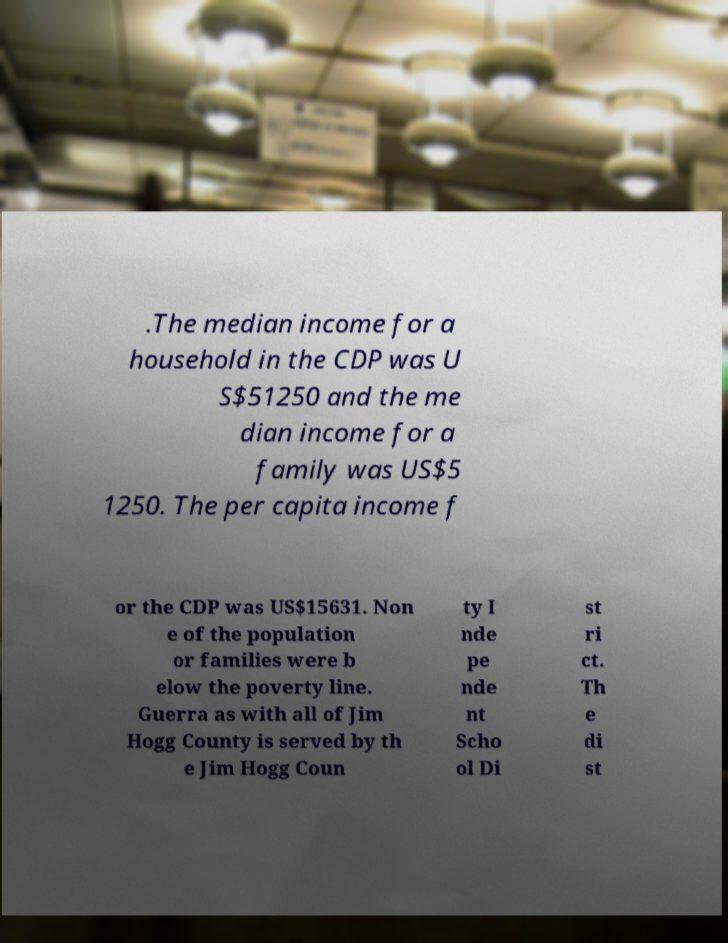Can you accurately transcribe the text from the provided image for me? .The median income for a household in the CDP was U S$51250 and the me dian income for a family was US$5 1250. The per capita income f or the CDP was US$15631. Non e of the population or families were b elow the poverty line. Guerra as with all of Jim Hogg County is served by th e Jim Hogg Coun ty I nde pe nde nt Scho ol Di st ri ct. Th e di st 